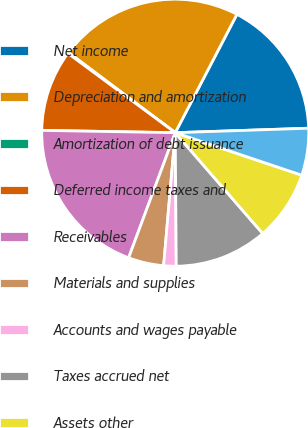Convert chart. <chart><loc_0><loc_0><loc_500><loc_500><pie_chart><fcel>Net income<fcel>Depreciation and amortization<fcel>Amortization of debt issuance<fcel>Deferred income taxes and<fcel>Receivables<fcel>Materials and supplies<fcel>Accounts and wages payable<fcel>Taxes accrued net<fcel>Assets other<fcel>Liabilities other<nl><fcel>16.82%<fcel>22.39%<fcel>0.12%<fcel>9.86%<fcel>19.6%<fcel>4.29%<fcel>1.51%<fcel>11.25%<fcel>8.47%<fcel>5.69%<nl></chart> 